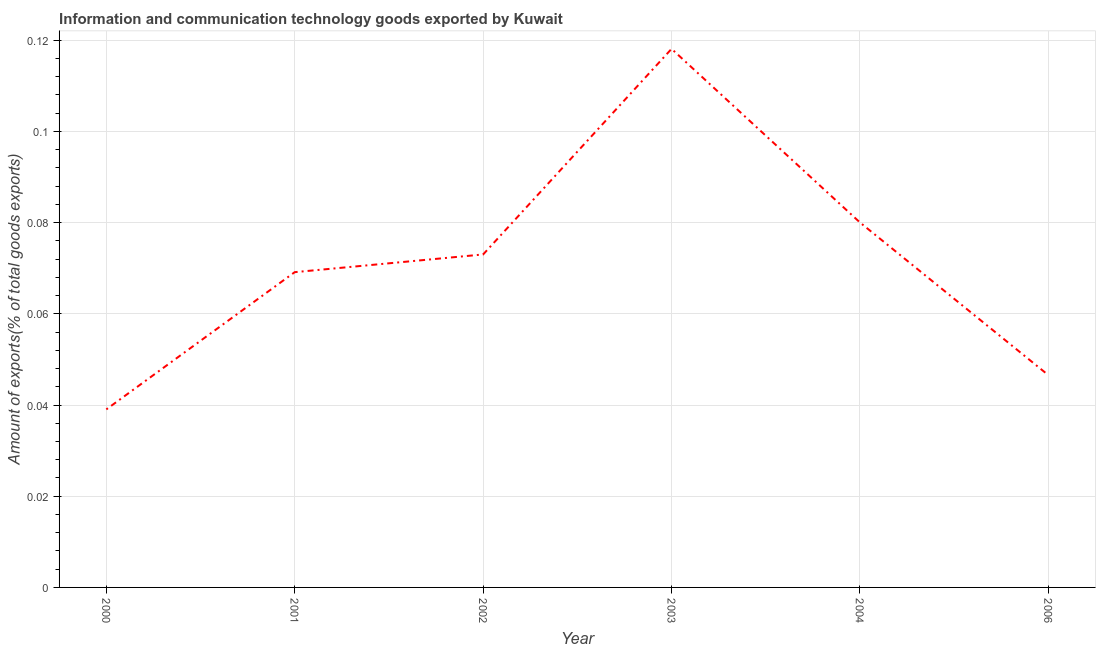What is the amount of ict goods exports in 2001?
Your answer should be compact. 0.07. Across all years, what is the maximum amount of ict goods exports?
Provide a succinct answer. 0.12. Across all years, what is the minimum amount of ict goods exports?
Provide a succinct answer. 0.04. In which year was the amount of ict goods exports maximum?
Provide a succinct answer. 2003. What is the sum of the amount of ict goods exports?
Make the answer very short. 0.43. What is the difference between the amount of ict goods exports in 2002 and 2004?
Make the answer very short. -0.01. What is the average amount of ict goods exports per year?
Offer a terse response. 0.07. What is the median amount of ict goods exports?
Offer a very short reply. 0.07. What is the ratio of the amount of ict goods exports in 2001 to that in 2003?
Keep it short and to the point. 0.59. What is the difference between the highest and the second highest amount of ict goods exports?
Give a very brief answer. 0.04. Is the sum of the amount of ict goods exports in 2003 and 2006 greater than the maximum amount of ict goods exports across all years?
Ensure brevity in your answer.  Yes. What is the difference between the highest and the lowest amount of ict goods exports?
Offer a terse response. 0.08. Does the amount of ict goods exports monotonically increase over the years?
Your response must be concise. No. How many lines are there?
Offer a very short reply. 1. What is the difference between two consecutive major ticks on the Y-axis?
Give a very brief answer. 0.02. Are the values on the major ticks of Y-axis written in scientific E-notation?
Your answer should be compact. No. What is the title of the graph?
Your answer should be very brief. Information and communication technology goods exported by Kuwait. What is the label or title of the Y-axis?
Give a very brief answer. Amount of exports(% of total goods exports). What is the Amount of exports(% of total goods exports) of 2000?
Provide a succinct answer. 0.04. What is the Amount of exports(% of total goods exports) of 2001?
Provide a succinct answer. 0.07. What is the Amount of exports(% of total goods exports) of 2002?
Give a very brief answer. 0.07. What is the Amount of exports(% of total goods exports) in 2003?
Give a very brief answer. 0.12. What is the Amount of exports(% of total goods exports) of 2004?
Keep it short and to the point. 0.08. What is the Amount of exports(% of total goods exports) in 2006?
Offer a very short reply. 0.05. What is the difference between the Amount of exports(% of total goods exports) in 2000 and 2001?
Make the answer very short. -0.03. What is the difference between the Amount of exports(% of total goods exports) in 2000 and 2002?
Your answer should be compact. -0.03. What is the difference between the Amount of exports(% of total goods exports) in 2000 and 2003?
Your answer should be compact. -0.08. What is the difference between the Amount of exports(% of total goods exports) in 2000 and 2004?
Offer a very short reply. -0.04. What is the difference between the Amount of exports(% of total goods exports) in 2000 and 2006?
Give a very brief answer. -0.01. What is the difference between the Amount of exports(% of total goods exports) in 2001 and 2002?
Provide a short and direct response. -0. What is the difference between the Amount of exports(% of total goods exports) in 2001 and 2003?
Your response must be concise. -0.05. What is the difference between the Amount of exports(% of total goods exports) in 2001 and 2004?
Your response must be concise. -0.01. What is the difference between the Amount of exports(% of total goods exports) in 2001 and 2006?
Ensure brevity in your answer.  0.02. What is the difference between the Amount of exports(% of total goods exports) in 2002 and 2003?
Make the answer very short. -0.05. What is the difference between the Amount of exports(% of total goods exports) in 2002 and 2004?
Your answer should be compact. -0.01. What is the difference between the Amount of exports(% of total goods exports) in 2002 and 2006?
Your answer should be compact. 0.03. What is the difference between the Amount of exports(% of total goods exports) in 2003 and 2004?
Provide a succinct answer. 0.04. What is the difference between the Amount of exports(% of total goods exports) in 2003 and 2006?
Ensure brevity in your answer.  0.07. What is the difference between the Amount of exports(% of total goods exports) in 2004 and 2006?
Your answer should be compact. 0.03. What is the ratio of the Amount of exports(% of total goods exports) in 2000 to that in 2001?
Give a very brief answer. 0.56. What is the ratio of the Amount of exports(% of total goods exports) in 2000 to that in 2002?
Give a very brief answer. 0.54. What is the ratio of the Amount of exports(% of total goods exports) in 2000 to that in 2003?
Offer a very short reply. 0.33. What is the ratio of the Amount of exports(% of total goods exports) in 2000 to that in 2004?
Your answer should be compact. 0.49. What is the ratio of the Amount of exports(% of total goods exports) in 2000 to that in 2006?
Your response must be concise. 0.84. What is the ratio of the Amount of exports(% of total goods exports) in 2001 to that in 2002?
Your answer should be compact. 0.95. What is the ratio of the Amount of exports(% of total goods exports) in 2001 to that in 2003?
Provide a short and direct response. 0.58. What is the ratio of the Amount of exports(% of total goods exports) in 2001 to that in 2004?
Keep it short and to the point. 0.86. What is the ratio of the Amount of exports(% of total goods exports) in 2001 to that in 2006?
Provide a short and direct response. 1.49. What is the ratio of the Amount of exports(% of total goods exports) in 2002 to that in 2003?
Give a very brief answer. 0.62. What is the ratio of the Amount of exports(% of total goods exports) in 2002 to that in 2004?
Your response must be concise. 0.91. What is the ratio of the Amount of exports(% of total goods exports) in 2002 to that in 2006?
Offer a terse response. 1.57. What is the ratio of the Amount of exports(% of total goods exports) in 2003 to that in 2004?
Your answer should be very brief. 1.48. What is the ratio of the Amount of exports(% of total goods exports) in 2003 to that in 2006?
Your answer should be compact. 2.54. What is the ratio of the Amount of exports(% of total goods exports) in 2004 to that in 2006?
Offer a very short reply. 1.72. 